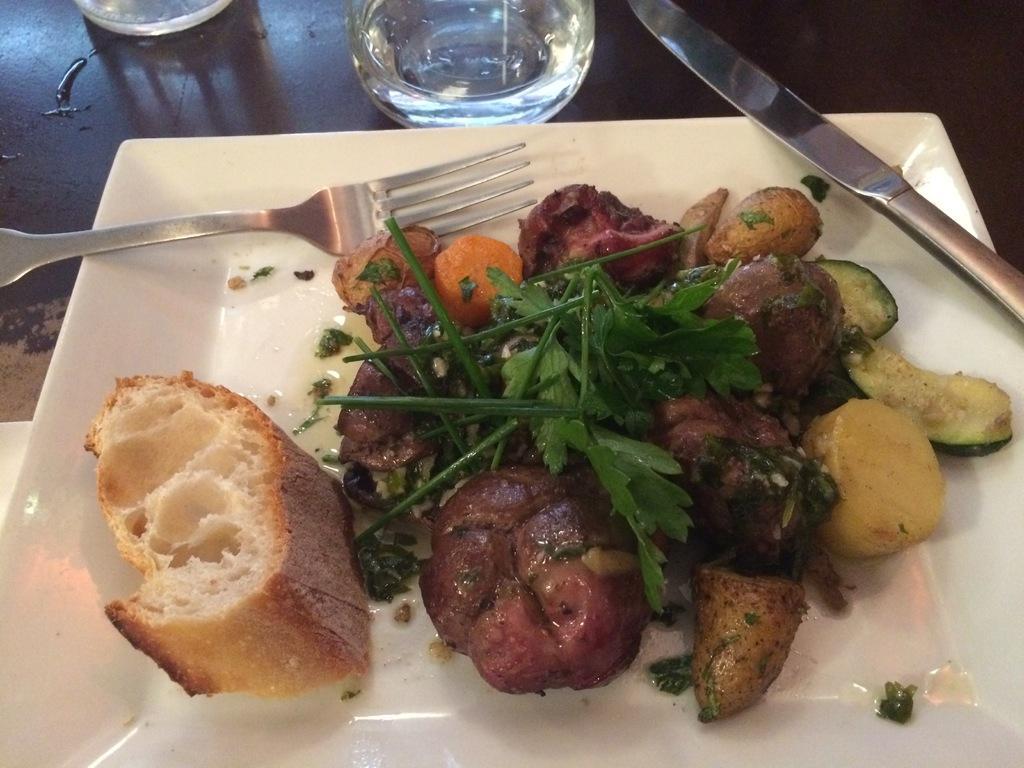Could you give a brief overview of what you see in this image? In this image I can see the plate with food. I can see the food is colorful and the plate is in white color. I can also see the fork and the knife on the plate. To the side I can see the glasses. These are on the black and brown color surface. 